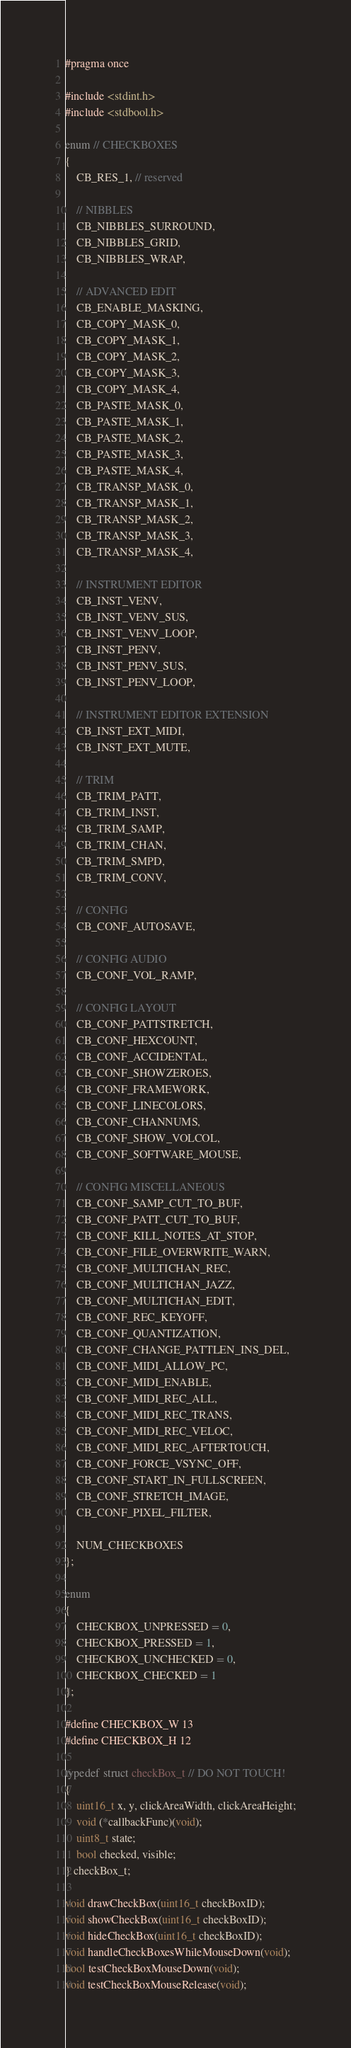<code> <loc_0><loc_0><loc_500><loc_500><_C_>#pragma once

#include <stdint.h>
#include <stdbool.h>

enum // CHECKBOXES
{
	CB_RES_1, // reserved

	// NIBBLES
	CB_NIBBLES_SURROUND,
	CB_NIBBLES_GRID,
	CB_NIBBLES_WRAP,

	// ADVANCED EDIT
	CB_ENABLE_MASKING,
	CB_COPY_MASK_0,
	CB_COPY_MASK_1,
	CB_COPY_MASK_2,
	CB_COPY_MASK_3,
	CB_COPY_MASK_4,
	CB_PASTE_MASK_0,
	CB_PASTE_MASK_1,
	CB_PASTE_MASK_2,
	CB_PASTE_MASK_3,
	CB_PASTE_MASK_4,
	CB_TRANSP_MASK_0,
	CB_TRANSP_MASK_1,
	CB_TRANSP_MASK_2,
	CB_TRANSP_MASK_3,
	CB_TRANSP_MASK_4,

	// INSTRUMENT EDITOR
	CB_INST_VENV,
	CB_INST_VENV_SUS,
	CB_INST_VENV_LOOP,
	CB_INST_PENV,
	CB_INST_PENV_SUS,
	CB_INST_PENV_LOOP,

	// INSTRUMENT EDITOR EXTENSION
	CB_INST_EXT_MIDI,
	CB_INST_EXT_MUTE,

	// TRIM
	CB_TRIM_PATT,
	CB_TRIM_INST,
	CB_TRIM_SAMP,
	CB_TRIM_CHAN,
	CB_TRIM_SMPD,
	CB_TRIM_CONV,

	// CONFIG
	CB_CONF_AUTOSAVE,

	// CONFIG AUDIO
	CB_CONF_VOL_RAMP,

	// CONFIG LAYOUT
	CB_CONF_PATTSTRETCH,
	CB_CONF_HEXCOUNT,
	CB_CONF_ACCIDENTAL,
	CB_CONF_SHOWZEROES,
	CB_CONF_FRAMEWORK,
	CB_CONF_LINECOLORS,
	CB_CONF_CHANNUMS,
	CB_CONF_SHOW_VOLCOL,
	CB_CONF_SOFTWARE_MOUSE,

	// CONFIG MISCELLANEOUS
	CB_CONF_SAMP_CUT_TO_BUF,
	CB_CONF_PATT_CUT_TO_BUF,
	CB_CONF_KILL_NOTES_AT_STOP,
	CB_CONF_FILE_OVERWRITE_WARN,
	CB_CONF_MULTICHAN_REC,
	CB_CONF_MULTICHAN_JAZZ,
	CB_CONF_MULTICHAN_EDIT,
	CB_CONF_REC_KEYOFF,
	CB_CONF_QUANTIZATION,
	CB_CONF_CHANGE_PATTLEN_INS_DEL,
	CB_CONF_MIDI_ALLOW_PC,
	CB_CONF_MIDI_ENABLE,
	CB_CONF_MIDI_REC_ALL,
	CB_CONF_MIDI_REC_TRANS,
	CB_CONF_MIDI_REC_VELOC,
	CB_CONF_MIDI_REC_AFTERTOUCH,
	CB_CONF_FORCE_VSYNC_OFF,
	CB_CONF_START_IN_FULLSCREEN,
	CB_CONF_STRETCH_IMAGE,
	CB_CONF_PIXEL_FILTER,

	NUM_CHECKBOXES
};

enum
{
	CHECKBOX_UNPRESSED = 0,
	CHECKBOX_PRESSED = 1,
	CHECKBOX_UNCHECKED = 0,
	CHECKBOX_CHECKED = 1
};

#define CHECKBOX_W 13
#define CHECKBOX_H 12

typedef struct checkBox_t // DO NOT TOUCH!
{
	uint16_t x, y, clickAreaWidth, clickAreaHeight;
	void (*callbackFunc)(void);
	uint8_t state;
	bool checked, visible;
} checkBox_t;

void drawCheckBox(uint16_t checkBoxID);
void showCheckBox(uint16_t checkBoxID);
void hideCheckBox(uint16_t checkBoxID);
void handleCheckBoxesWhileMouseDown(void);
bool testCheckBoxMouseDown(void);
void testCheckBoxMouseRelease(void);
</code> 